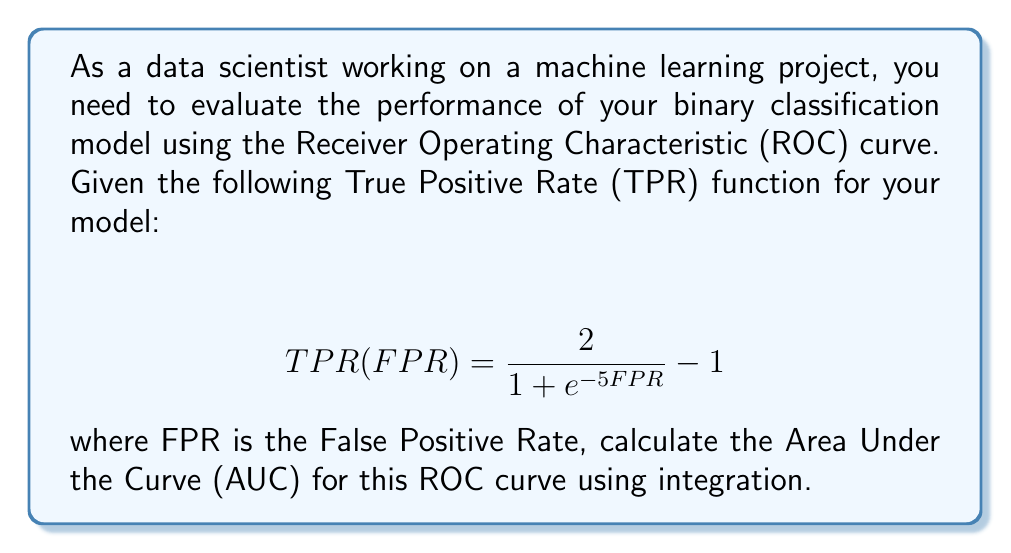Can you solve this math problem? To calculate the Area Under the Curve (AUC) for the given ROC curve, we need to integrate the TPR function with respect to FPR from 0 to 1. Here's the step-by-step process:

1. Set up the integral:
   $$ AUC = \int_0^1 TPR(FPR) \, dFPR $$

2. Substitute the given TPR function:
   $$ AUC = \int_0^1 \left(\frac{2}{1 + e^{-5FPR}} - 1\right) \, dFPR $$

3. To simplify the integration, let's make a substitution:
   Let $u = e^{-5FPR}$, then $du = -5e^{-5FPR} \, dFPR$
   
   When $FPR = 0$, $u = e^0 = 1$
   When $FPR = 1$, $u = e^{-5} = \frac{1}{e^5}$

4. Rewrite the integral with the substitution:
   $$ AUC = -\frac{1}{5} \int_1^{1/e^5} \left(\frac{2}{1 + u} - 1\right) \, du $$

5. Integrate:
   $$ AUC = -\frac{1}{5} \left[2\ln(1+u) - u\right]_1^{1/e^5} $$

6. Evaluate the integral:
   $$ AUC = -\frac{1}{5} \left[2\ln(1+\frac{1}{e^5}) - \frac{1}{e^5} - (2\ln(1+1) - 1)\right] $$

7. Simplify:
   $$ AUC = -\frac{1}{5} \left[2\ln(1+\frac{1}{e^5}) - \frac{1}{e^5} - (2\ln(2) - 1)\right] $$

8. Calculate the final result (you can use Python to compute this value):
   $$ AUC \approx 0.9241 $$
Answer: $0.9241$ 